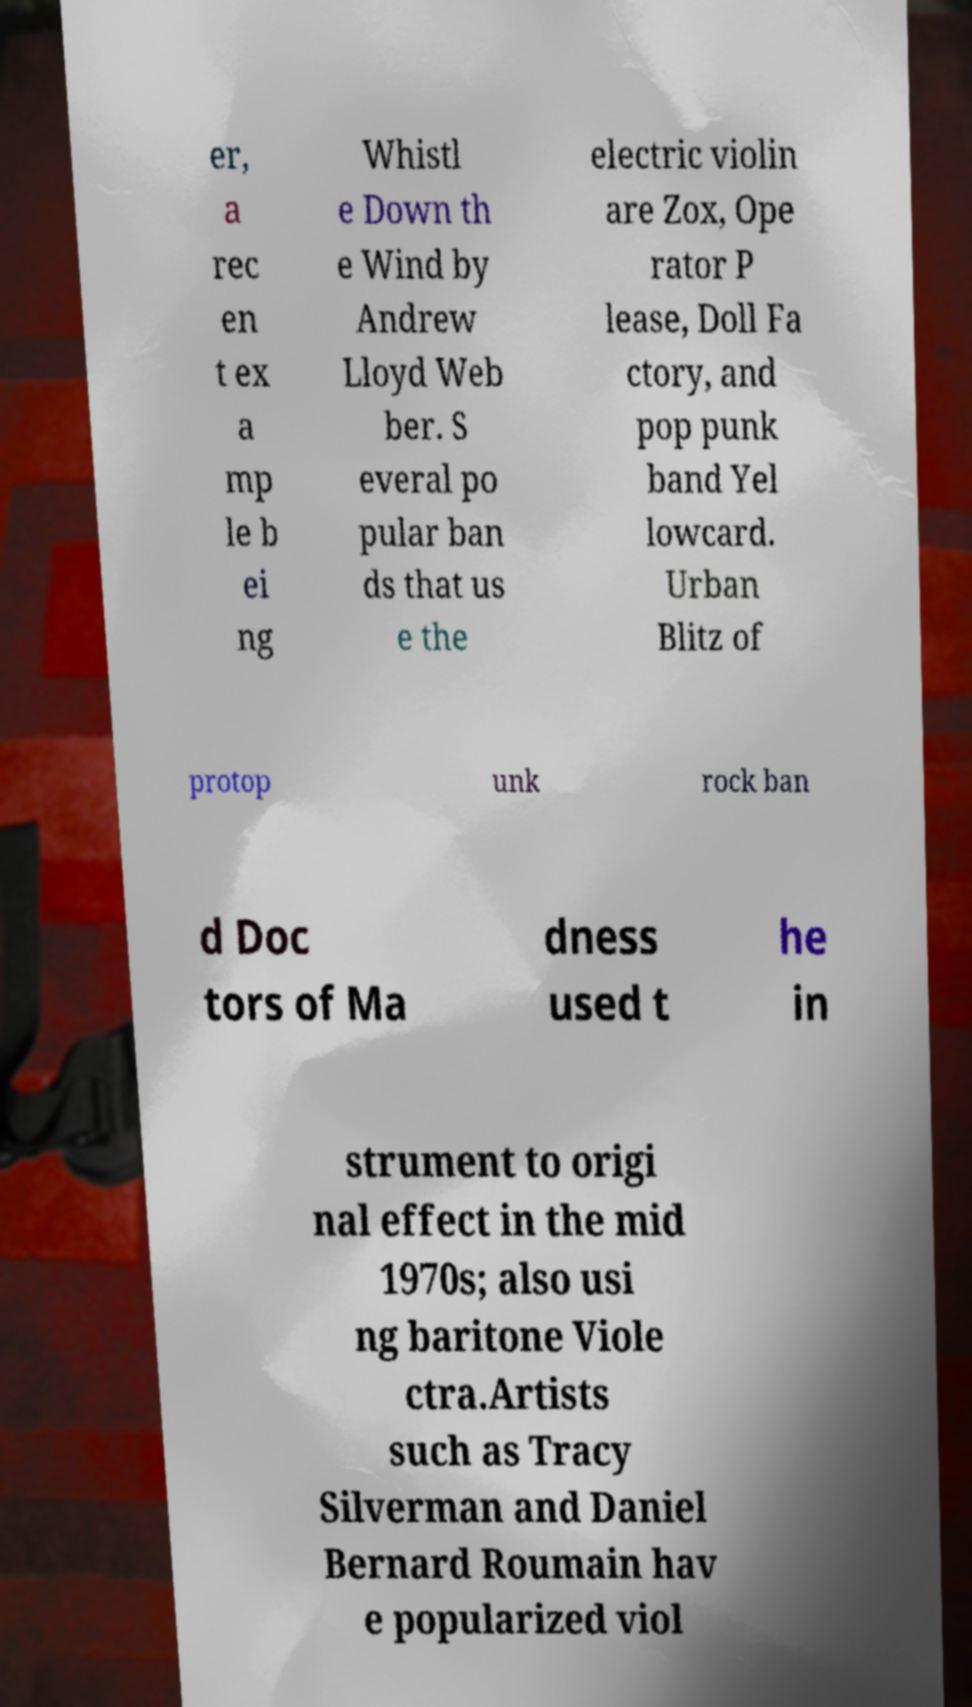There's text embedded in this image that I need extracted. Can you transcribe it verbatim? er, a rec en t ex a mp le b ei ng Whistl e Down th e Wind by Andrew Lloyd Web ber. S everal po pular ban ds that us e the electric violin are Zox, Ope rator P lease, Doll Fa ctory, and pop punk band Yel lowcard. Urban Blitz of protop unk rock ban d Doc tors of Ma dness used t he in strument to origi nal effect in the mid 1970s; also usi ng baritone Viole ctra.Artists such as Tracy Silverman and Daniel Bernard Roumain hav e popularized viol 